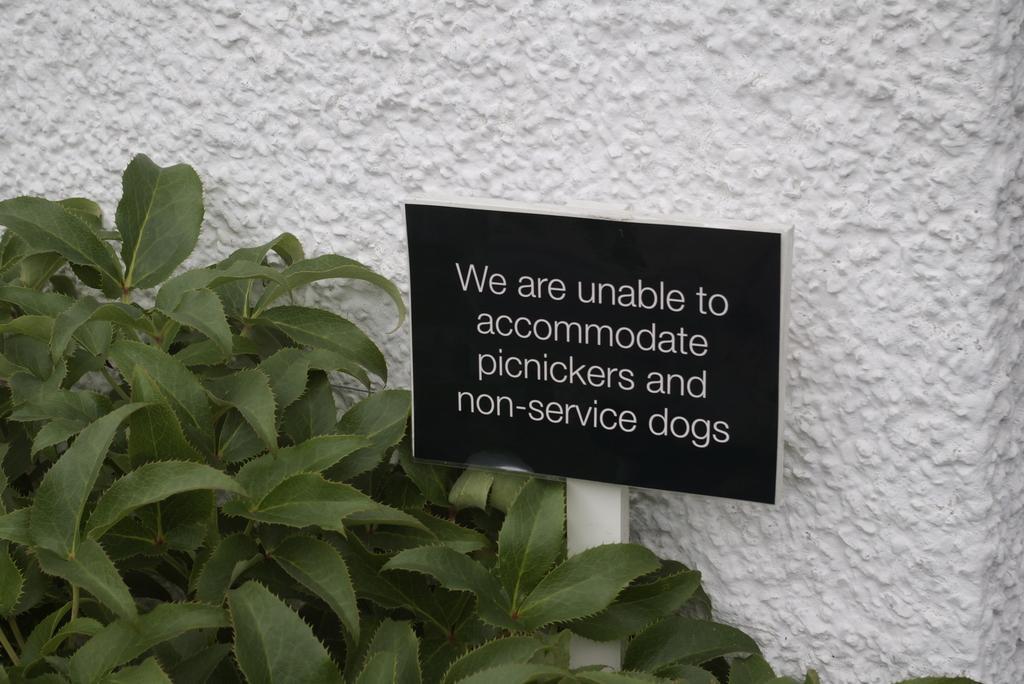How would you summarize this image in a sentence or two? In this image I can see a board with some text written on it. On the left side I can see the leaves. In the background, I can see the wall. 